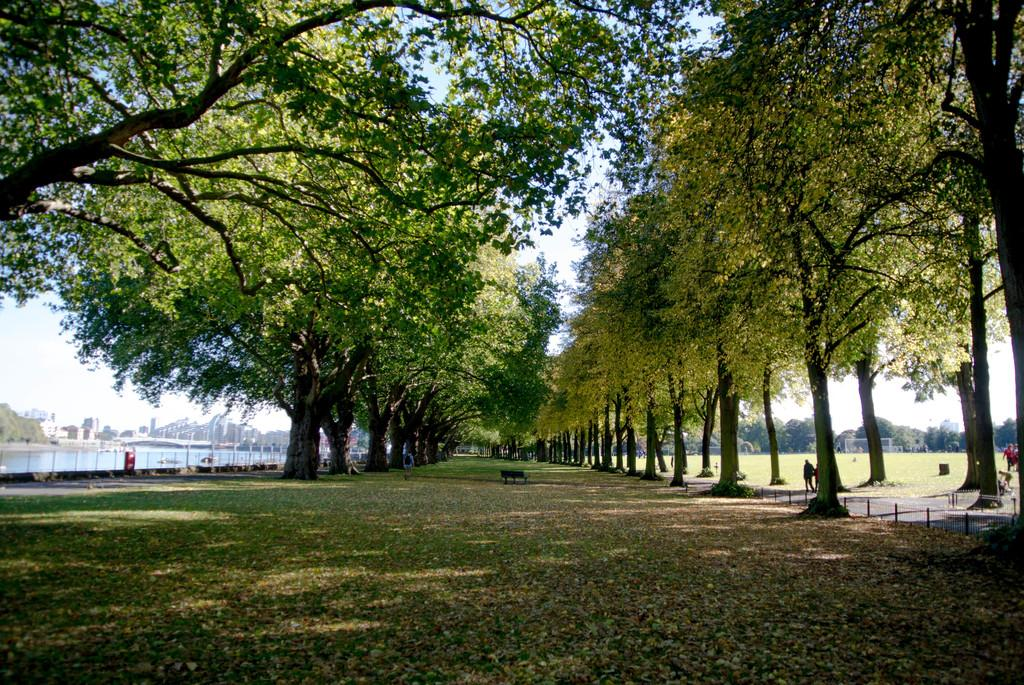What type of vegetation is present in the image? There is grass in the image. What type of seating is visible in the image? There is a bench in the image. What are the people in the image doing? People are walking on the road in the image. What other natural elements can be seen in the image? There are trees in the image. What can be seen in the image that is not a natural element? There is water visible in the image, as well as buildings. What is visible in the background of the image? The sky is visible in the background of the image. What type of spade is being used by the achiever in the image? There is no spade or achiever present in the image. How does the grip of the spade affect the performance of the achiever in the image? There is no spade or achiever present in the image, so it is not possible to discuss the grip or performance. 